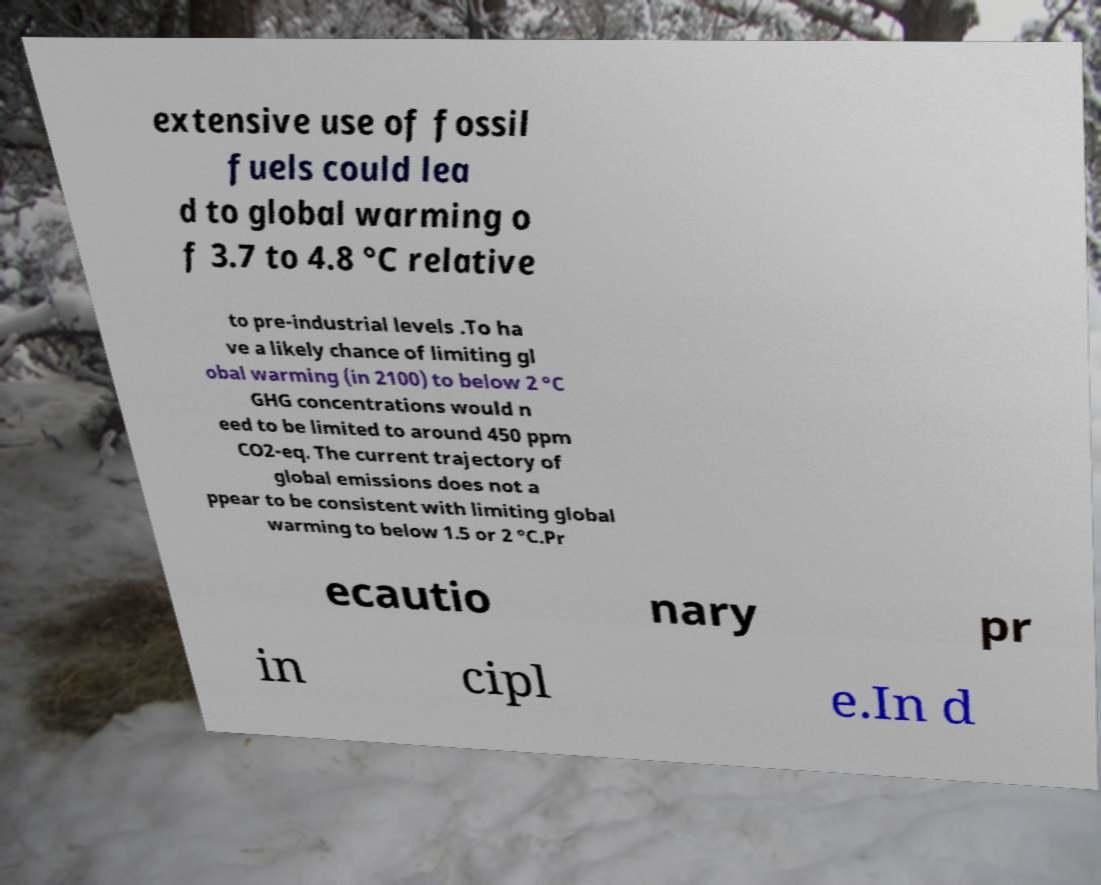Please read and relay the text visible in this image. What does it say? extensive use of fossil fuels could lea d to global warming o f 3.7 to 4.8 °C relative to pre-industrial levels .To ha ve a likely chance of limiting gl obal warming (in 2100) to below 2 °C GHG concentrations would n eed to be limited to around 450 ppm CO2-eq. The current trajectory of global emissions does not a ppear to be consistent with limiting global warming to below 1.5 or 2 °C.Pr ecautio nary pr in cipl e.In d 